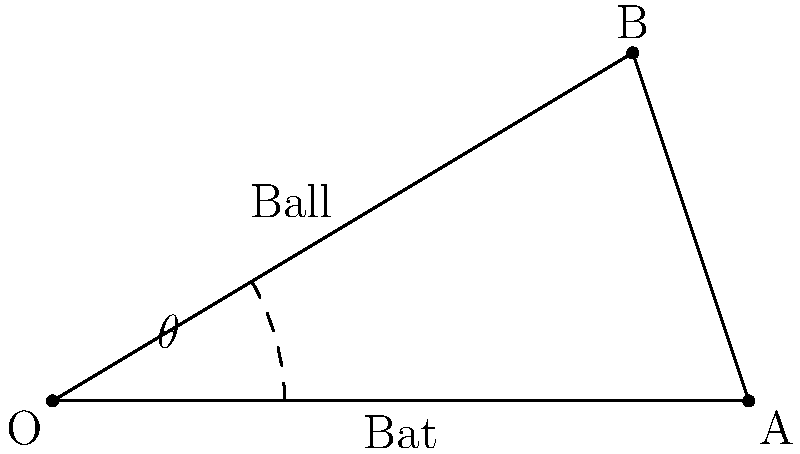During a baseball game, you notice that the angle between the bat and the ball at the point of contact is crucial for a successful hit. If the bat (OA) is 33 inches long and the distance from the point of contact to the end of the bat (AB) is 6 inches, what is the angle $\theta$ between the bat and the ball? Let's approach this step-by-step:

1) We have a right-angled triangle OAB, where:
   - OA is the length of the bat (33 inches)
   - AB is the distance from the point of contact to the end of the bat (6 inches)
   - Angle BOA is the angle we're looking for ($\theta$)

2) We can use the cosine function to find this angle:

   $\cos \theta = \frac{\text{adjacent}}{\text{hypotenuse}} = \frac{OA - AB}{OA}$

3) Substituting the values:

   $\cos \theta = \frac{33 - 6}{33} = \frac{27}{33} = 0.8181818...$

4) To find $\theta$, we need to take the inverse cosine (arccos) of this value:

   $\theta = \arccos(0.8181818...)$

5) Using a calculator or computer:

   $\theta \approx 35.21$ degrees

Therefore, the angle between the bat and the ball at the point of contact is approximately 35.21 degrees.
Answer: $35.21^\circ$ 